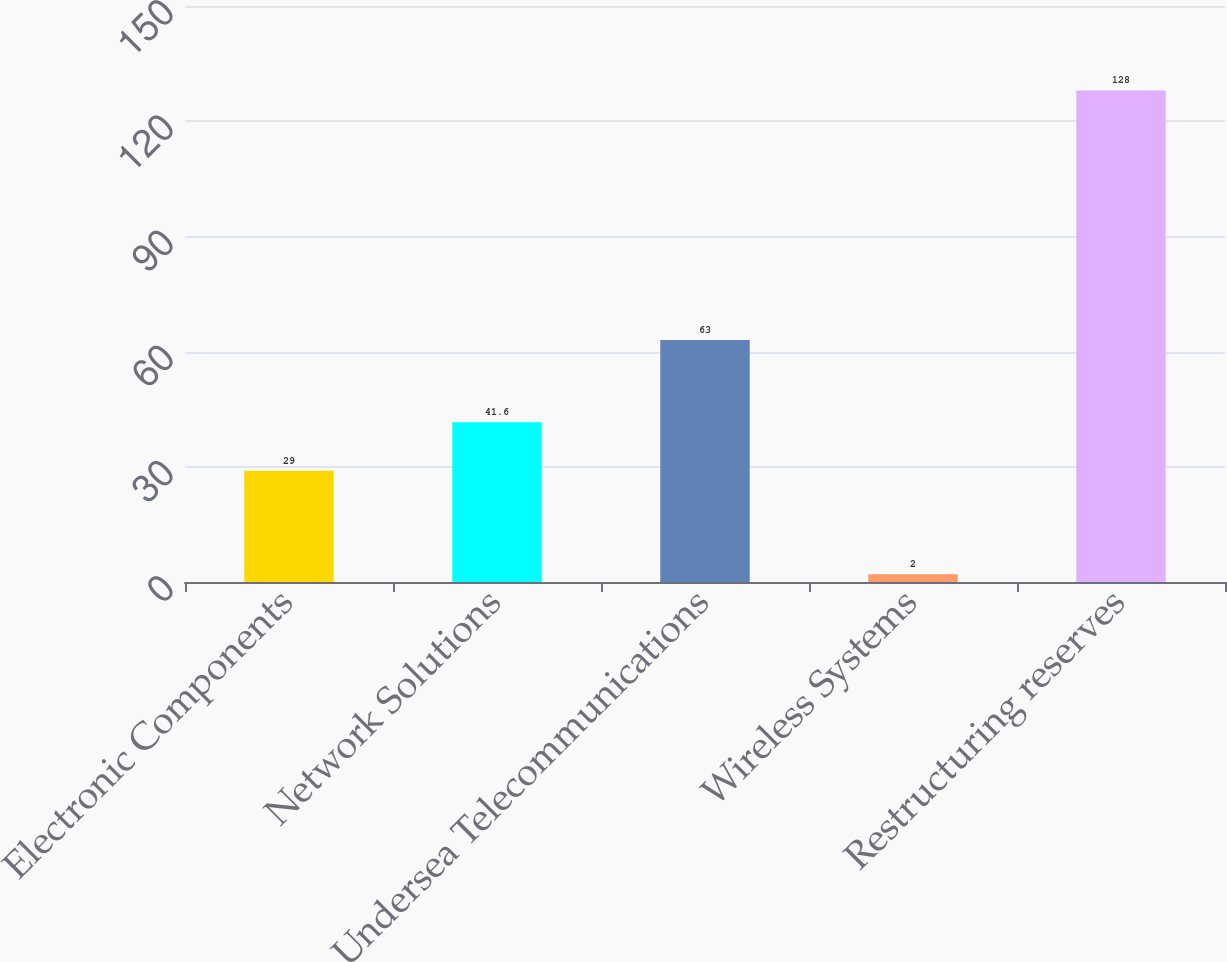<chart> <loc_0><loc_0><loc_500><loc_500><bar_chart><fcel>Electronic Components<fcel>Network Solutions<fcel>Undersea Telecommunications<fcel>Wireless Systems<fcel>Restructuring reserves<nl><fcel>29<fcel>41.6<fcel>63<fcel>2<fcel>128<nl></chart> 